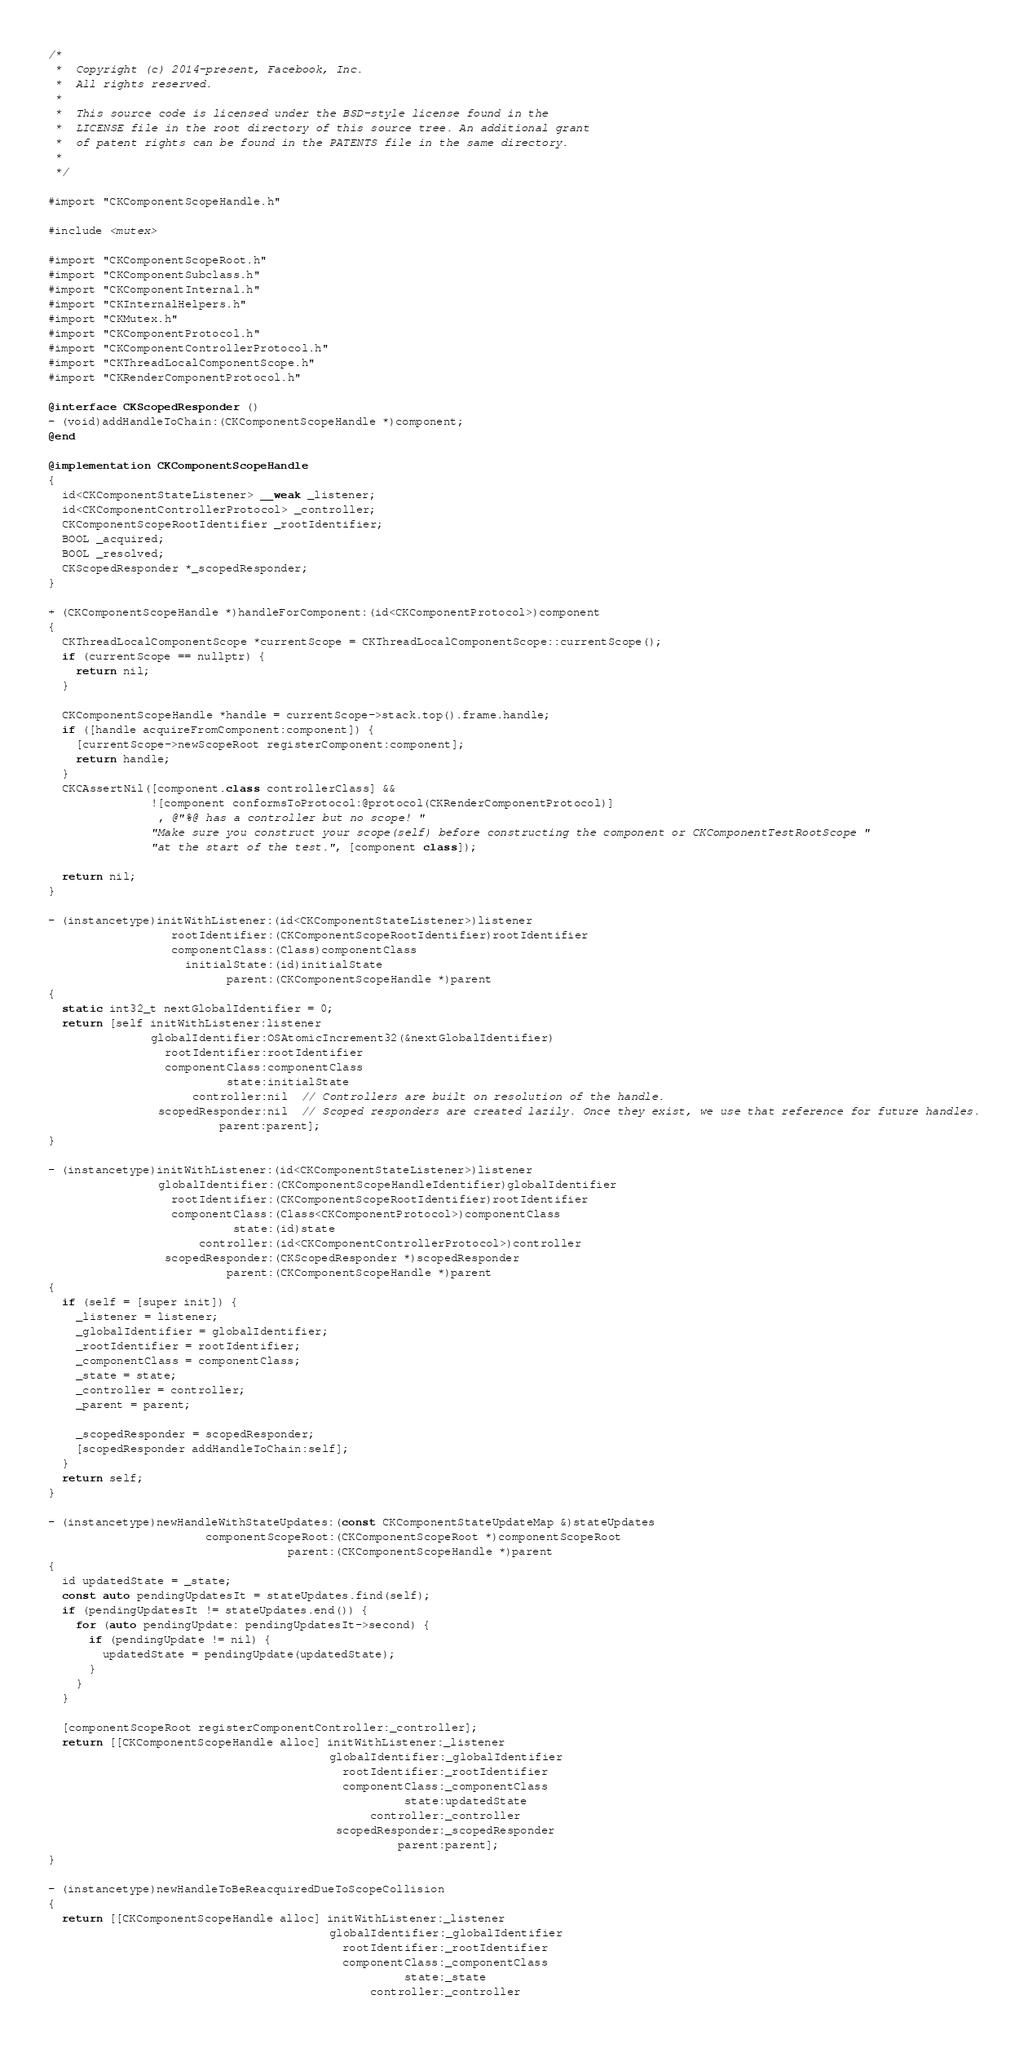<code> <loc_0><loc_0><loc_500><loc_500><_ObjectiveC_>/*
 *  Copyright (c) 2014-present, Facebook, Inc.
 *  All rights reserved.
 *
 *  This source code is licensed under the BSD-style license found in the
 *  LICENSE file in the root directory of this source tree. An additional grant
 *  of patent rights can be found in the PATENTS file in the same directory.
 *
 */

#import "CKComponentScopeHandle.h"

#include <mutex>

#import "CKComponentScopeRoot.h"
#import "CKComponentSubclass.h"
#import "CKComponentInternal.h"
#import "CKInternalHelpers.h"
#import "CKMutex.h"
#import "CKComponentProtocol.h"
#import "CKComponentControllerProtocol.h"
#import "CKThreadLocalComponentScope.h"
#import "CKRenderComponentProtocol.h"

@interface CKScopedResponder ()
- (void)addHandleToChain:(CKComponentScopeHandle *)component;
@end

@implementation CKComponentScopeHandle
{
  id<CKComponentStateListener> __weak _listener;
  id<CKComponentControllerProtocol> _controller;
  CKComponentScopeRootIdentifier _rootIdentifier;
  BOOL _acquired;
  BOOL _resolved;
  CKScopedResponder *_scopedResponder;
}

+ (CKComponentScopeHandle *)handleForComponent:(id<CKComponentProtocol>)component
{
  CKThreadLocalComponentScope *currentScope = CKThreadLocalComponentScope::currentScope();
  if (currentScope == nullptr) {
    return nil;
  }

  CKComponentScopeHandle *handle = currentScope->stack.top().frame.handle;
  if ([handle acquireFromComponent:component]) {
    [currentScope->newScopeRoot registerComponent:component];
    return handle;
  }
  CKCAssertNil([component.class controllerClass] &&
               ![component conformsToProtocol:@protocol(CKRenderComponentProtocol)]
                , @"%@ has a controller but no scope! "
               "Make sure you construct your scope(self) before constructing the component or CKComponentTestRootScope "
               "at the start of the test.", [component class]);

  return nil;
}

- (instancetype)initWithListener:(id<CKComponentStateListener>)listener
                  rootIdentifier:(CKComponentScopeRootIdentifier)rootIdentifier
                  componentClass:(Class)componentClass
                    initialState:(id)initialState
                          parent:(CKComponentScopeHandle *)parent
{
  static int32_t nextGlobalIdentifier = 0;
  return [self initWithListener:listener
               globalIdentifier:OSAtomicIncrement32(&nextGlobalIdentifier)
                 rootIdentifier:rootIdentifier
                 componentClass:componentClass
                          state:initialState
                     controller:nil  // Controllers are built on resolution of the handle.
                scopedResponder:nil  // Scoped responders are created lazily. Once they exist, we use that reference for future handles.
                         parent:parent];
}

- (instancetype)initWithListener:(id<CKComponentStateListener>)listener
                globalIdentifier:(CKComponentScopeHandleIdentifier)globalIdentifier
                  rootIdentifier:(CKComponentScopeRootIdentifier)rootIdentifier
                  componentClass:(Class<CKComponentProtocol>)componentClass
                           state:(id)state
                      controller:(id<CKComponentControllerProtocol>)controller
                 scopedResponder:(CKScopedResponder *)scopedResponder
                          parent:(CKComponentScopeHandle *)parent
{
  if (self = [super init]) {
    _listener = listener;
    _globalIdentifier = globalIdentifier;
    _rootIdentifier = rootIdentifier;
    _componentClass = componentClass;
    _state = state;
    _controller = controller;
    _parent = parent;

    _scopedResponder = scopedResponder;
    [scopedResponder addHandleToChain:self];
  }
  return self;
}

- (instancetype)newHandleWithStateUpdates:(const CKComponentStateUpdateMap &)stateUpdates
                       componentScopeRoot:(CKComponentScopeRoot *)componentScopeRoot
                                   parent:(CKComponentScopeHandle *)parent
{
  id updatedState = _state;
  const auto pendingUpdatesIt = stateUpdates.find(self);
  if (pendingUpdatesIt != stateUpdates.end()) {
    for (auto pendingUpdate: pendingUpdatesIt->second) {
      if (pendingUpdate != nil) {
        updatedState = pendingUpdate(updatedState);
      }
    }
  }

  [componentScopeRoot registerComponentController:_controller];
  return [[CKComponentScopeHandle alloc] initWithListener:_listener
                                         globalIdentifier:_globalIdentifier
                                           rootIdentifier:_rootIdentifier
                                           componentClass:_componentClass
                                                    state:updatedState
                                               controller:_controller
                                          scopedResponder:_scopedResponder
                                                   parent:parent];
}

- (instancetype)newHandleToBeReacquiredDueToScopeCollision
{
  return [[CKComponentScopeHandle alloc] initWithListener:_listener
                                         globalIdentifier:_globalIdentifier
                                           rootIdentifier:_rootIdentifier
                                           componentClass:_componentClass
                                                    state:_state
                                               controller:_controller</code> 